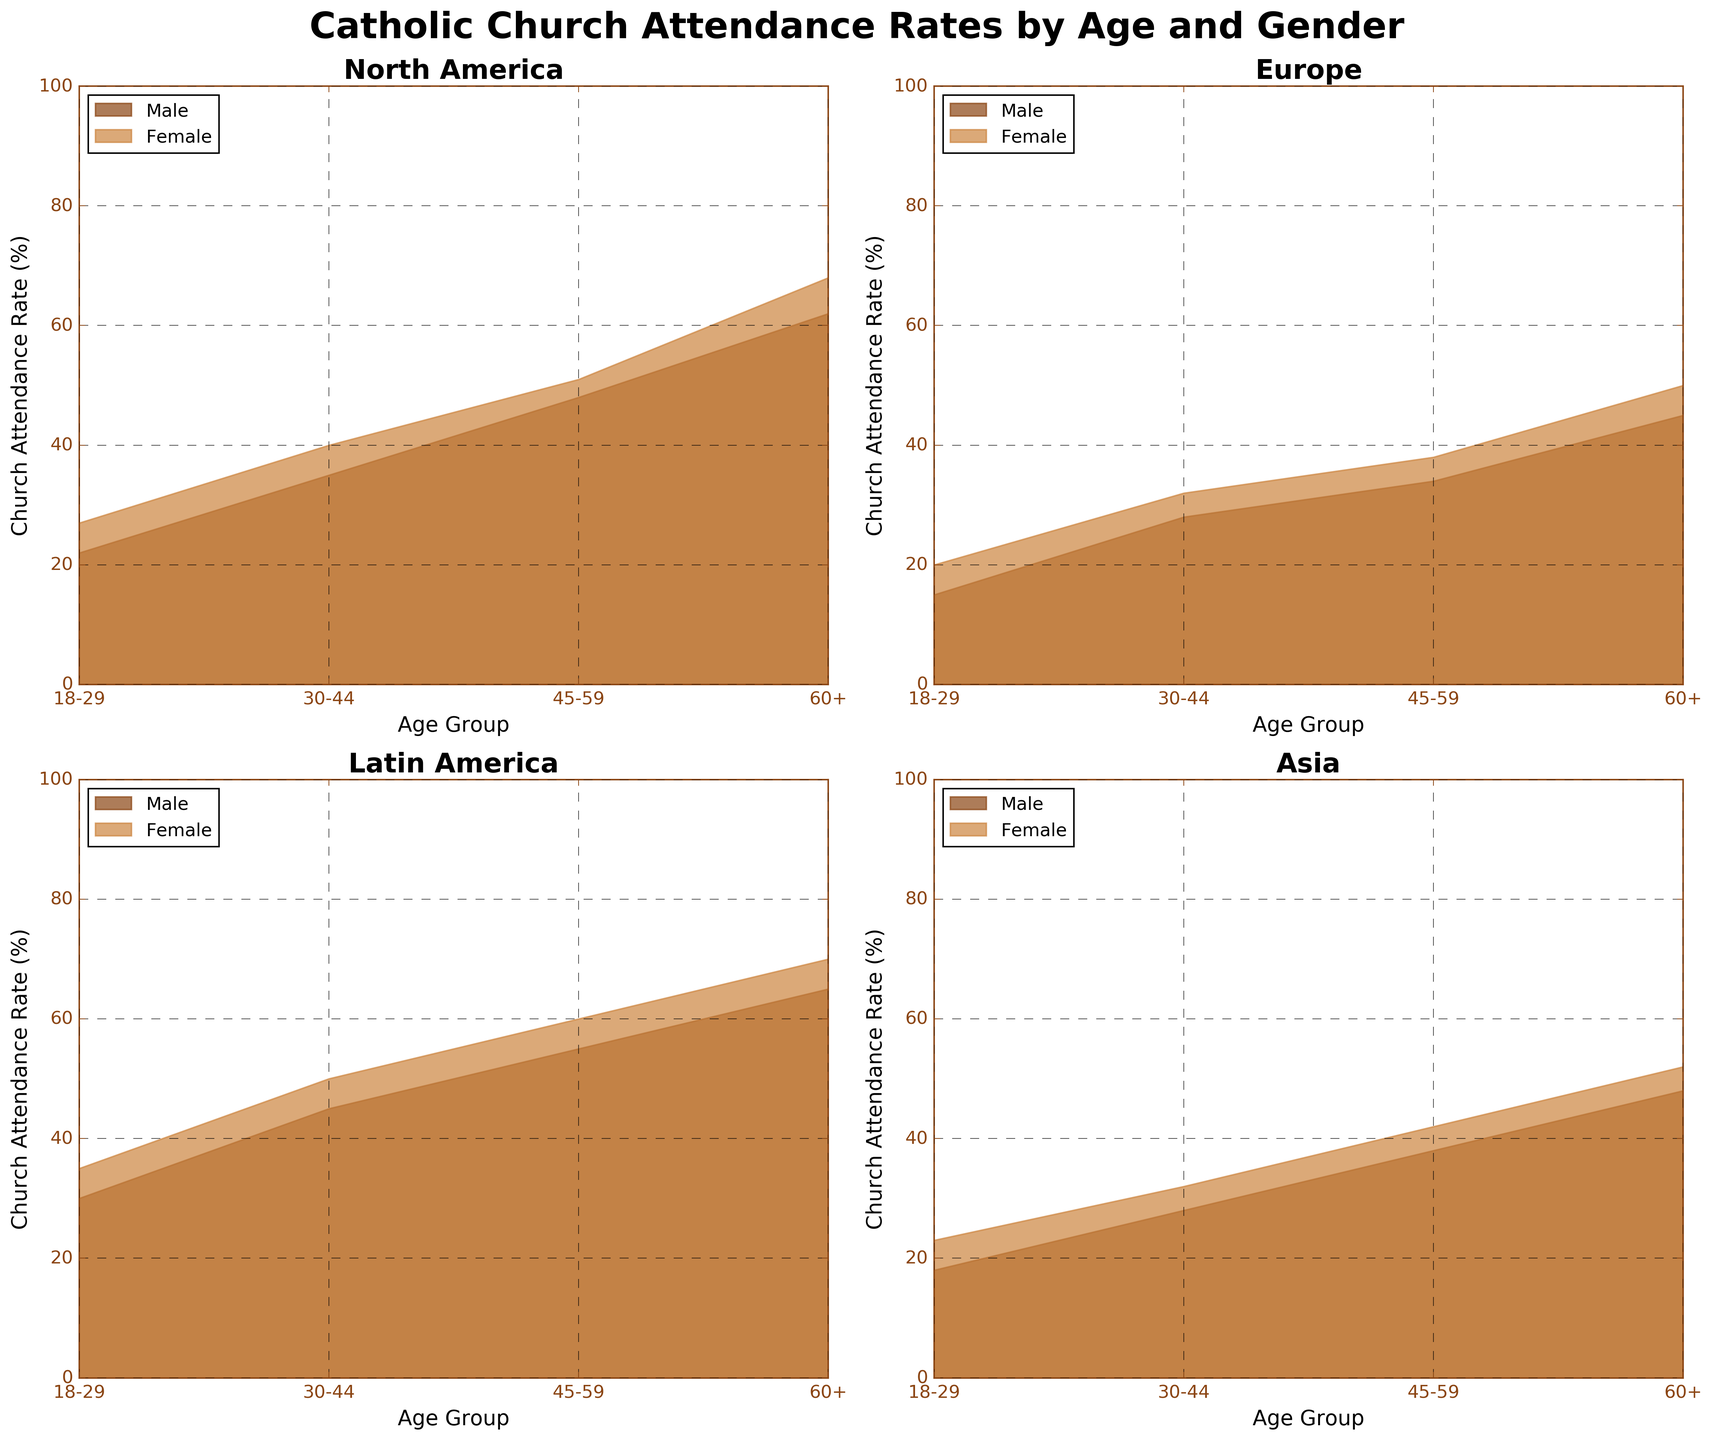How many subplots are present in the figure? The figure consists of a 2x2 grid of subplots, which means there is a total of 2 rows and 2 columns, leading to 2 * 2 = 4 subplots.
Answer: 4 Which age group in North America has the highest church attendance rate? By looking at the North America subplot, we see that the age group 60+ for both males and females has the highest rates, where women lead.
Answer: 60+ What is the difference between male and female church attendance rates for the 45-59 age group in Europe? In the Europe subplot, the church attendance rate for males aged 45-59 is 34%, and for females, it is 38%. The difference is 38 - 34 = 4%.
Answer: 4% What pattern can you observe in church attendance rates by age group in Latin America? The subplot for Latin America indicates an upward trend where church attendance rates increase with age, reaching the highest rates in the 60+ age group for both males and females.
Answer: Attendance increases with age Compare the church attendance rates of the 18-29 age group between Europe and Latin America. In Europe, the rates for males and females are 15% and 20%, respectively. In Latin America, the rates are 30% for males and 35% for females. Latin America has higher attendance rates for this age group in both genders.
Answer: Latin America has higher rates Which region has the lowest church attendance rate for females aged 18-29? By examining all female bars for the 18-29 age group across subplots, we can see that Europe shows the lowest rate, with 20%.
Answer: Europe What can you infer about the gender difference in church attendance rates in Asia for the age group 30-44? In the Asia subplot, males have a church attendance rate of 28%, and females have 32%. The females' rate is higher by 32 - 28 = 4%.
Answer: Females attend more Which region shows the greatest increase in church attendance rate from 18-29 to 30-44 for males? By comparing the rates between age groups 18-29 and 30-44 for males in each region: 
- North America: 35 - 22 = 13% 
- Europe: 28 - 15 = 13% 
- Latin America: 45 - 30 = 15% 
- Asia: 28 - 18 = 10%. 
Latin America shows the greatest increase with 15%.
Answer: Latin America 